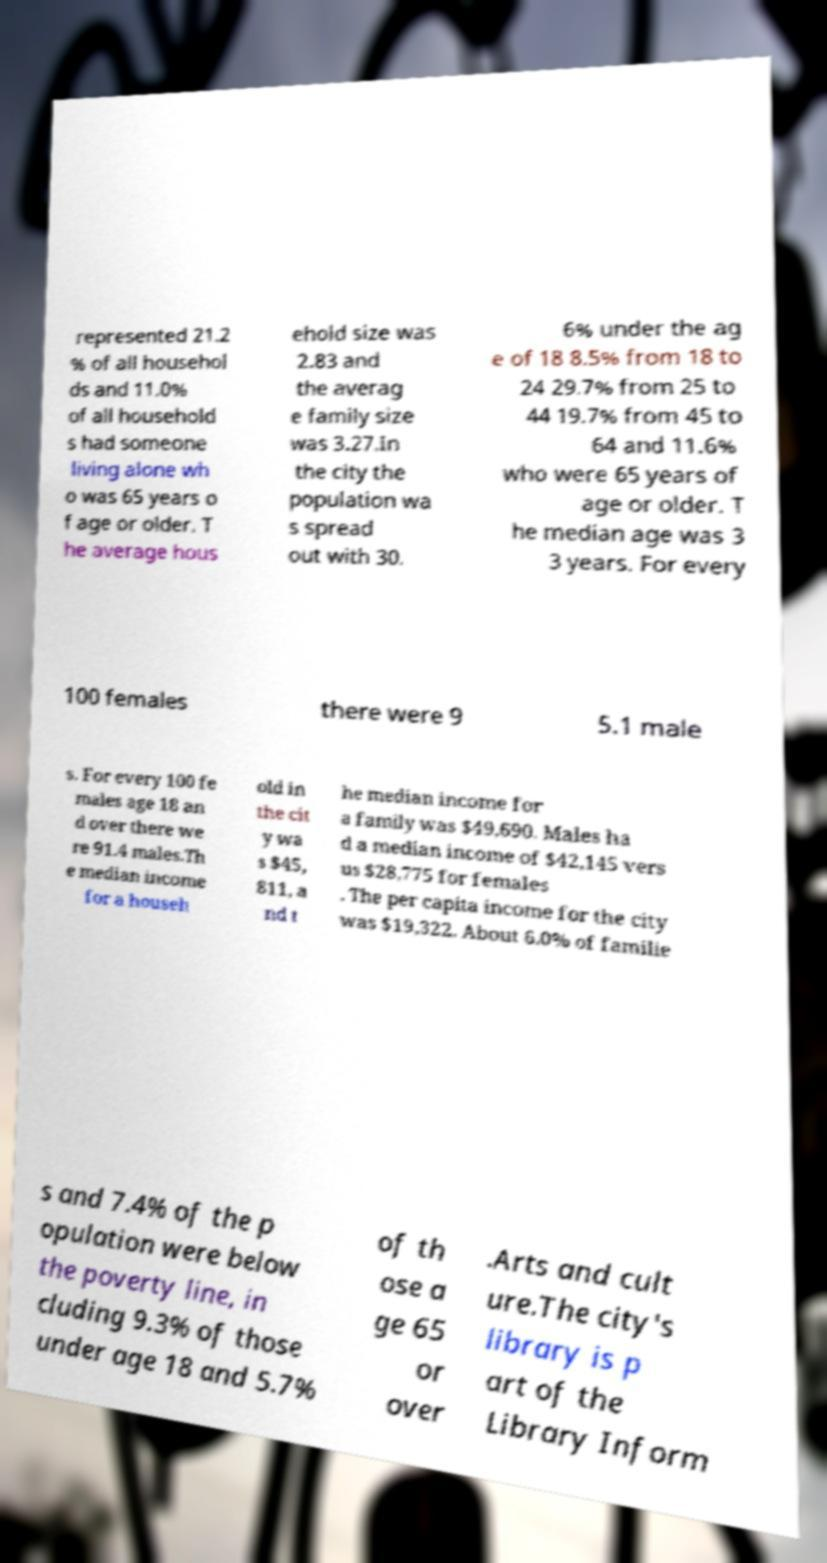There's text embedded in this image that I need extracted. Can you transcribe it verbatim? represented 21.2 % of all househol ds and 11.0% of all household s had someone living alone wh o was 65 years o f age or older. T he average hous ehold size was 2.83 and the averag e family size was 3.27.In the city the population wa s spread out with 30. 6% under the ag e of 18 8.5% from 18 to 24 29.7% from 25 to 44 19.7% from 45 to 64 and 11.6% who were 65 years of age or older. T he median age was 3 3 years. For every 100 females there were 9 5.1 male s. For every 100 fe males age 18 an d over there we re 91.4 males.Th e median income for a househ old in the cit y wa s $45, 811, a nd t he median income for a family was $49,690. Males ha d a median income of $42,145 vers us $28,775 for females . The per capita income for the city was $19,322. About 6.0% of familie s and 7.4% of the p opulation were below the poverty line, in cluding 9.3% of those under age 18 and 5.7% of th ose a ge 65 or over .Arts and cult ure.The city's library is p art of the Library Inform 